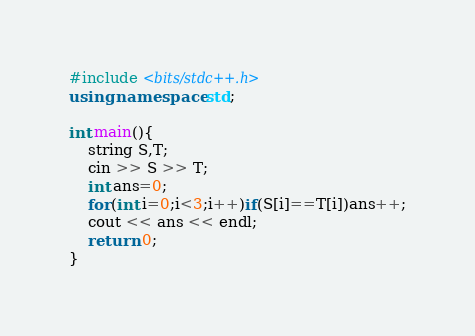<code> <loc_0><loc_0><loc_500><loc_500><_C++_>#include <bits/stdc++.h>
using namespace std;

int main(){
	string S,T;
	cin >> S >> T;
	int ans=0;
	for(int i=0;i<3;i++)if(S[i]==T[i])ans++;
	cout << ans << endl;
	return 0;
}</code> 